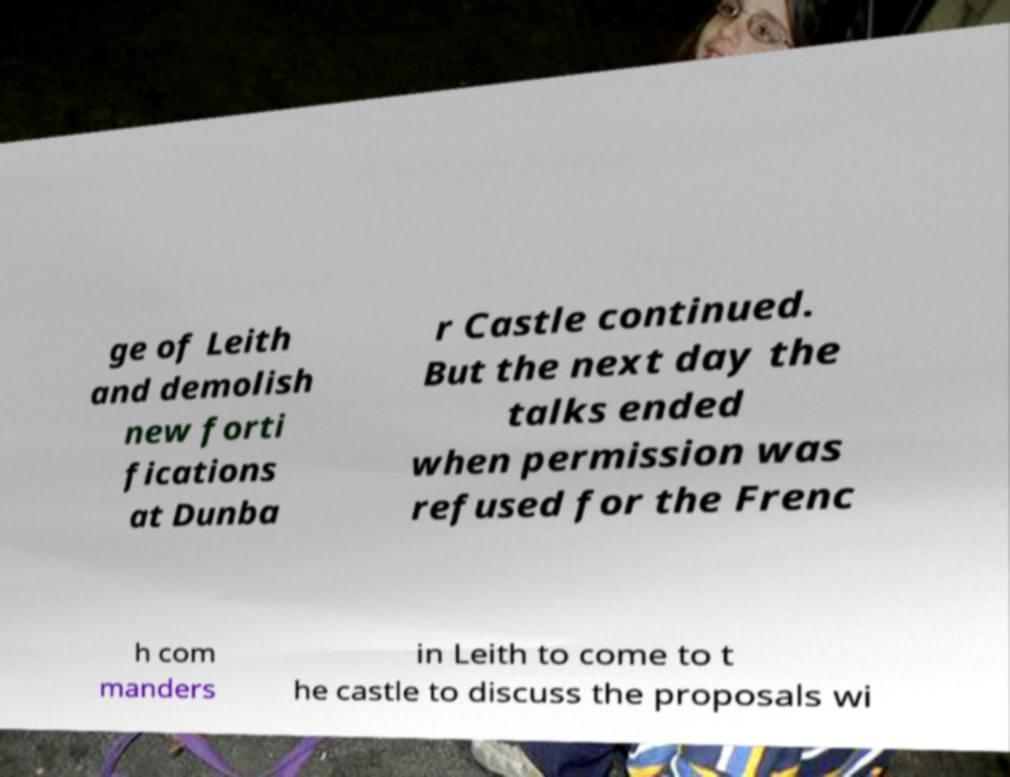For documentation purposes, I need the text within this image transcribed. Could you provide that? ge of Leith and demolish new forti fications at Dunba r Castle continued. But the next day the talks ended when permission was refused for the Frenc h com manders in Leith to come to t he castle to discuss the proposals wi 